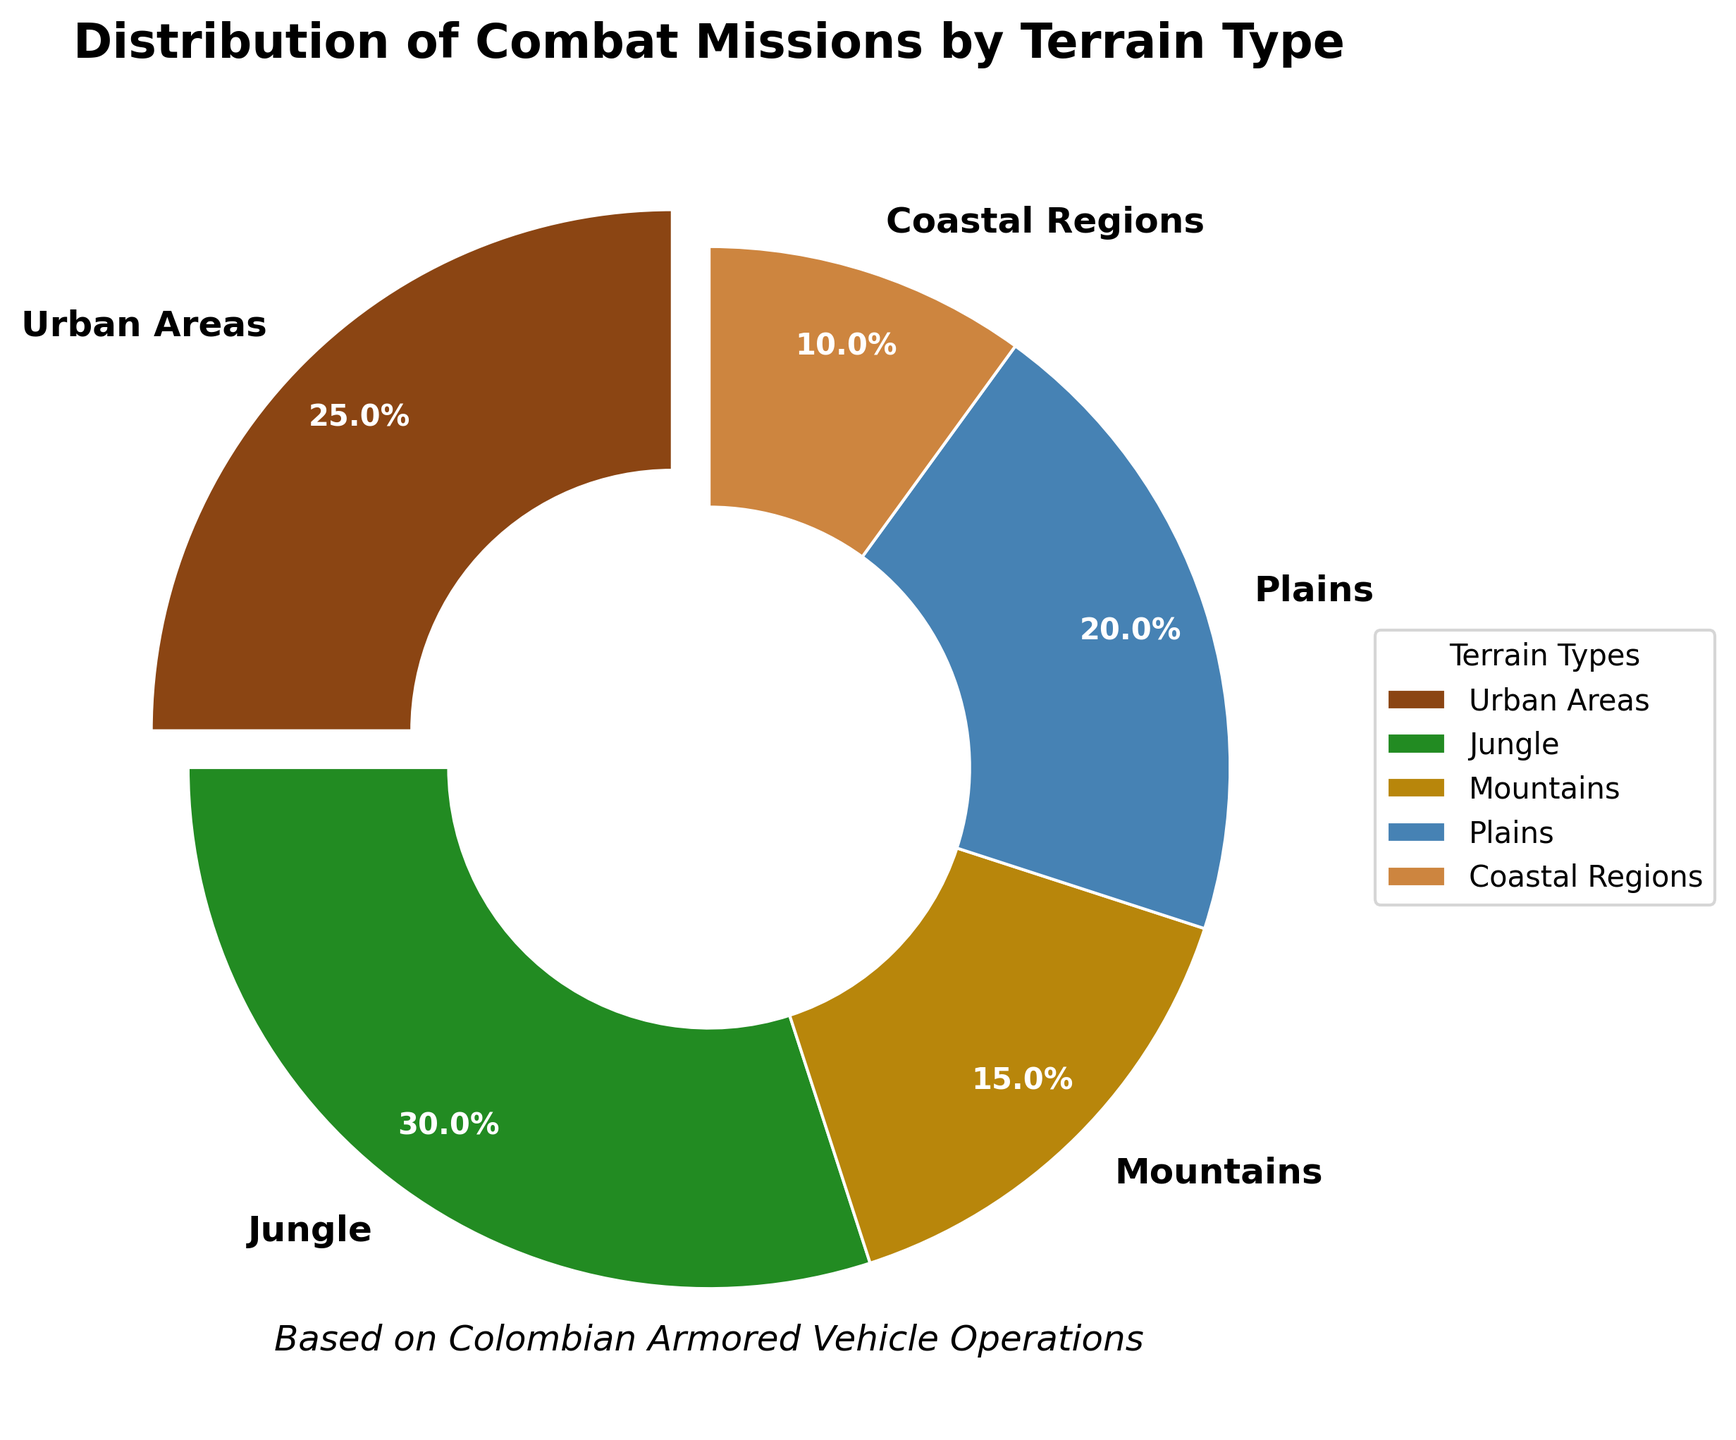What terrain type has the highest percentage of combat missions involving armored vehicles? The figure shows different terrain types and their respective percentages of combat missions. Observing the pie chart, Jungle has the largest section.
Answer: Jungle What terrain type has the lowest percentage of combat missions involving armored vehicles? By looking at the pie chart, Coastal Regions have the smallest section.
Answer: Coastal Regions How does the percentage of combat missions in Urban Areas compare to those in the Plains? The figure shows that Urban Areas have 25% and Plains have 20%. Therefore, Urban Areas have a higher percentage than Plains.
Answer: Urban Areas have a higher percentage What is the combined percentage of combat missions in Jungle and Mountains? Jungle has 30% and Mountains have 15%. Adding these percentages together results in 30% + 15% = 45%.
Answer: 45% Which terrain types have a greater percentage of combat missions than Plains? The figure shows that Jungle (30%) and Urban Areas (25%) both have higher percentages than Plains (20%).
Answer: Jungle and Urban Areas How much greater is the percentage of combat missions in Urban Areas compared to Coastal Regions? Urban Areas have 25% and Coastal Regions have 10%. The difference is 25% - 10% = 15%.
Answer: 15% What is the average percentage of combat missions across all terrain types? The percentages are 25%, 30%, 15%, 20%, and 10%. The sum of these is 100%, and there are 5 terrain types. Thus, the average is 100% / 5 = 20%.
Answer: 20% What percentage of combat missions occur in terrains classified as open (Plains and Coastal Regions)? Plains have 20% and Coastal Regions have 10%. Adding these together results in 20% + 10% = 30%.
Answer: 30% Which terrain type is represented by the brownish section in the pie chart? Observing the pie chart's color legend, the brownish section corresponds to Coastal Regions.
Answer: Coastal Regions What is the sum of the percentages of the three least represented terrain types? Mountains have 15%, Plains have 20%, and Coastal Regions have 10%. Summing these together gives 15% + 20% + 10% = 45%.
Answer: 45% 